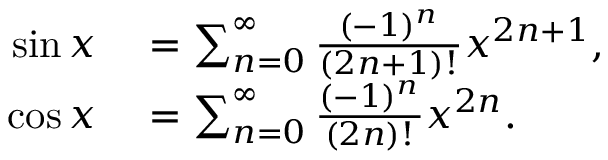Convert formula to latex. <formula><loc_0><loc_0><loc_500><loc_500>\begin{array} { r l } { \sin x } & = \sum _ { n = 0 } ^ { \infty } { \frac { ( - 1 ) ^ { n } } { ( 2 n + 1 ) ! } } x ^ { 2 n + 1 } , } \\ { \cos x } & = \sum _ { n = 0 } ^ { \infty } { \frac { ( - 1 ) ^ { n } } { ( 2 n ) ! } } x ^ { 2 n } . } \end{array}</formula> 